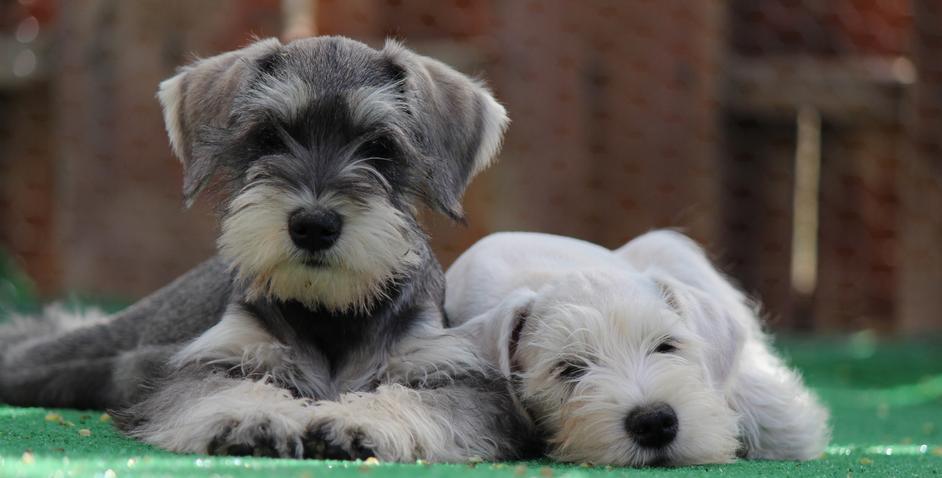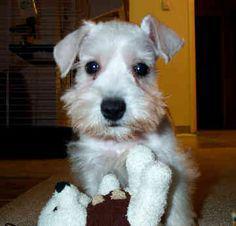The first image is the image on the left, the second image is the image on the right. For the images displayed, is the sentence "The left image contains at least two dogs." factually correct? Answer yes or no. Yes. The first image is the image on the left, the second image is the image on the right. For the images shown, is this caption "Each image contains one forward-facing schnauzer, and one image features a dog with a tag charm dangling under its chin." true? Answer yes or no. No. 